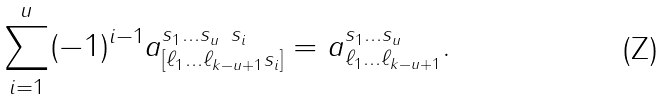Convert formula to latex. <formula><loc_0><loc_0><loc_500><loc_500>\sum _ { i = 1 } ^ { u } ( - 1 ) ^ { i - 1 } a _ { [ \ell _ { 1 } \dots \ell _ { k - u + 1 } s _ { i } ] } ^ { s _ { 1 } \dots s _ { u } \ s _ { i } } = a _ { \ell _ { 1 } \dots \ell _ { k - u + 1 } } ^ { s _ { 1 } \dots s _ { u } } .</formula> 